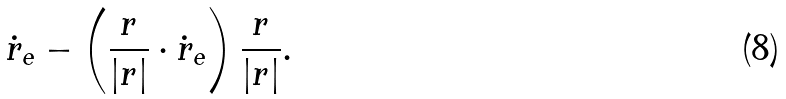<formula> <loc_0><loc_0><loc_500><loc_500>\dot { r } _ { e } - \left ( \frac { r } { | { r } | } \cdot \dot { r } _ { e } \right ) \frac { r } { | { r } | } .</formula> 